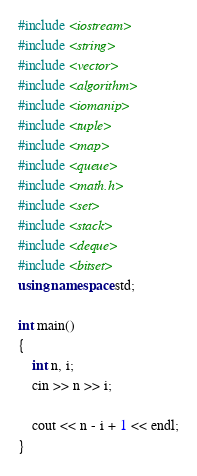Convert code to text. <code><loc_0><loc_0><loc_500><loc_500><_C++_>#include <iostream>
#include <string>
#include <vector>
#include <algorithm>
#include <iomanip>
#include <tuple>
#include <map>
#include <queue>
#include <math.h>
#include <set>
#include <stack>
#include <deque>
#include <bitset>
using namespace std;

int main()
{
	int n, i;
	cin >> n >> i;

	cout << n - i + 1 << endl;
}
</code> 